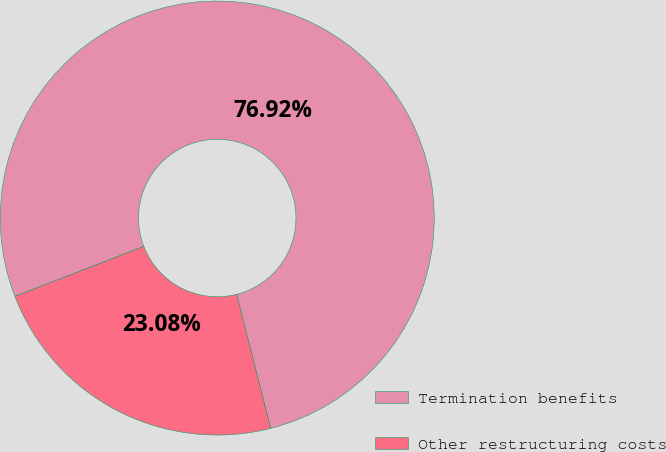<chart> <loc_0><loc_0><loc_500><loc_500><pie_chart><fcel>Termination benefits<fcel>Other restructuring costs<nl><fcel>76.92%<fcel>23.08%<nl></chart> 